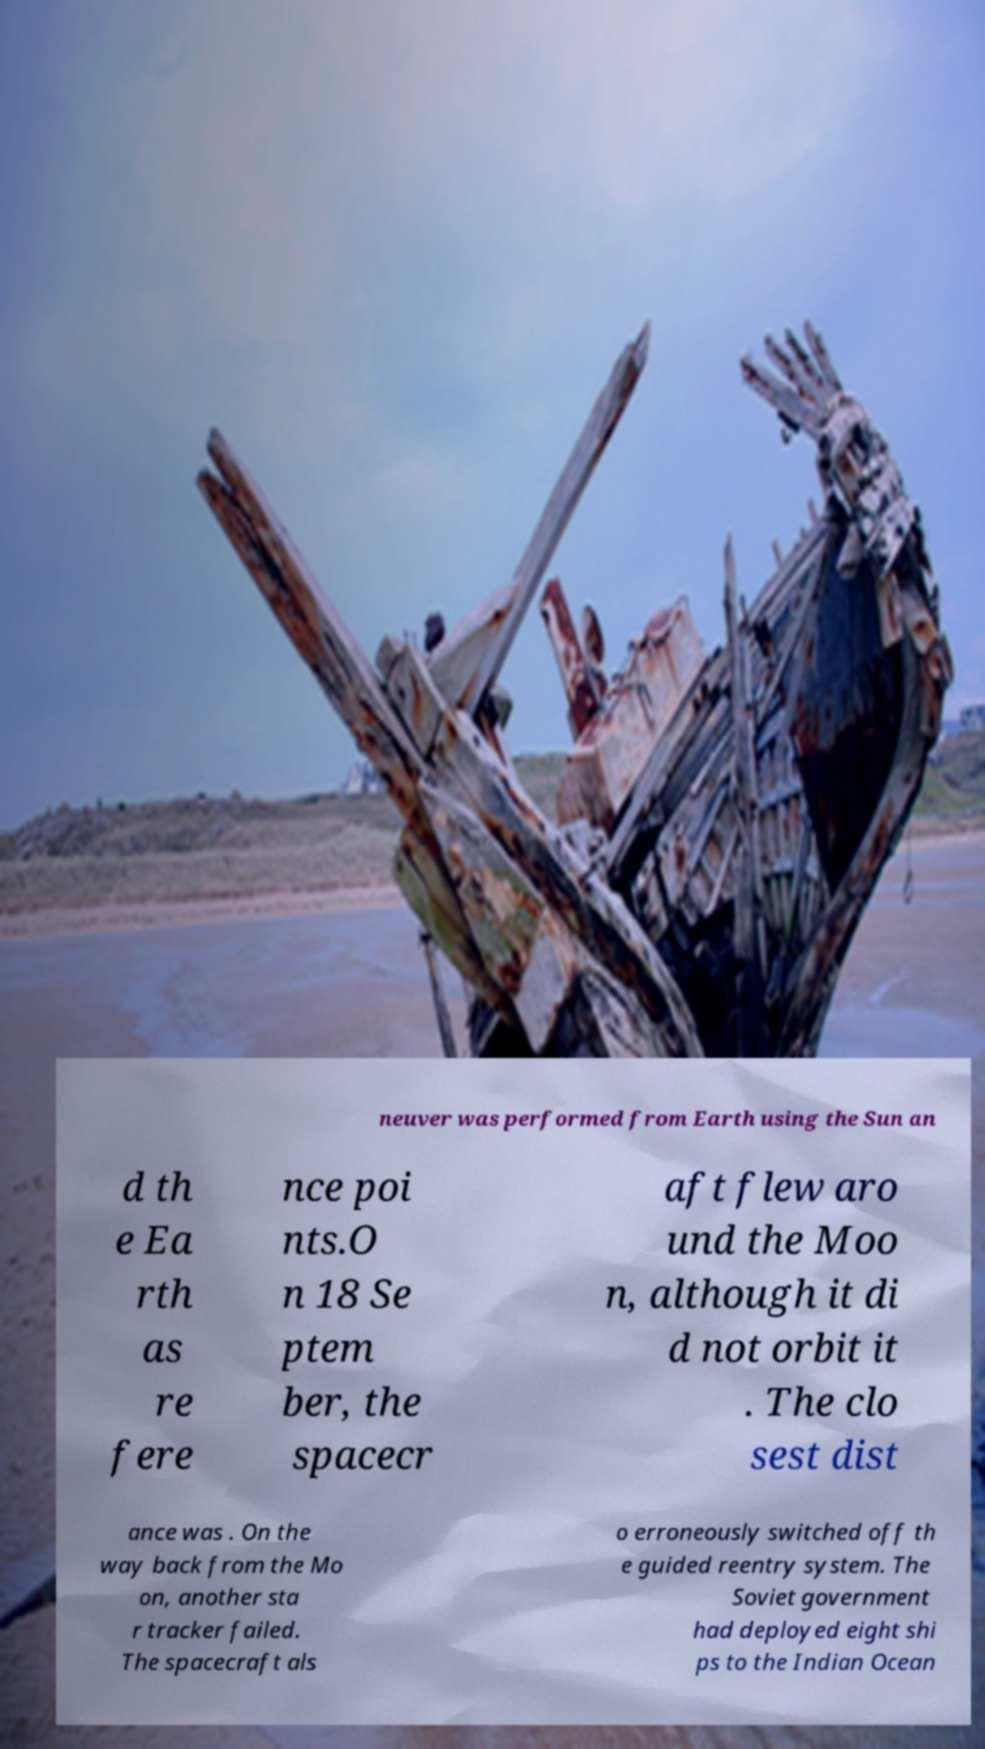Please identify and transcribe the text found in this image. neuver was performed from Earth using the Sun an d th e Ea rth as re fere nce poi nts.O n 18 Se ptem ber, the spacecr aft flew aro und the Moo n, although it di d not orbit it . The clo sest dist ance was . On the way back from the Mo on, another sta r tracker failed. The spacecraft als o erroneously switched off th e guided reentry system. The Soviet government had deployed eight shi ps to the Indian Ocean 